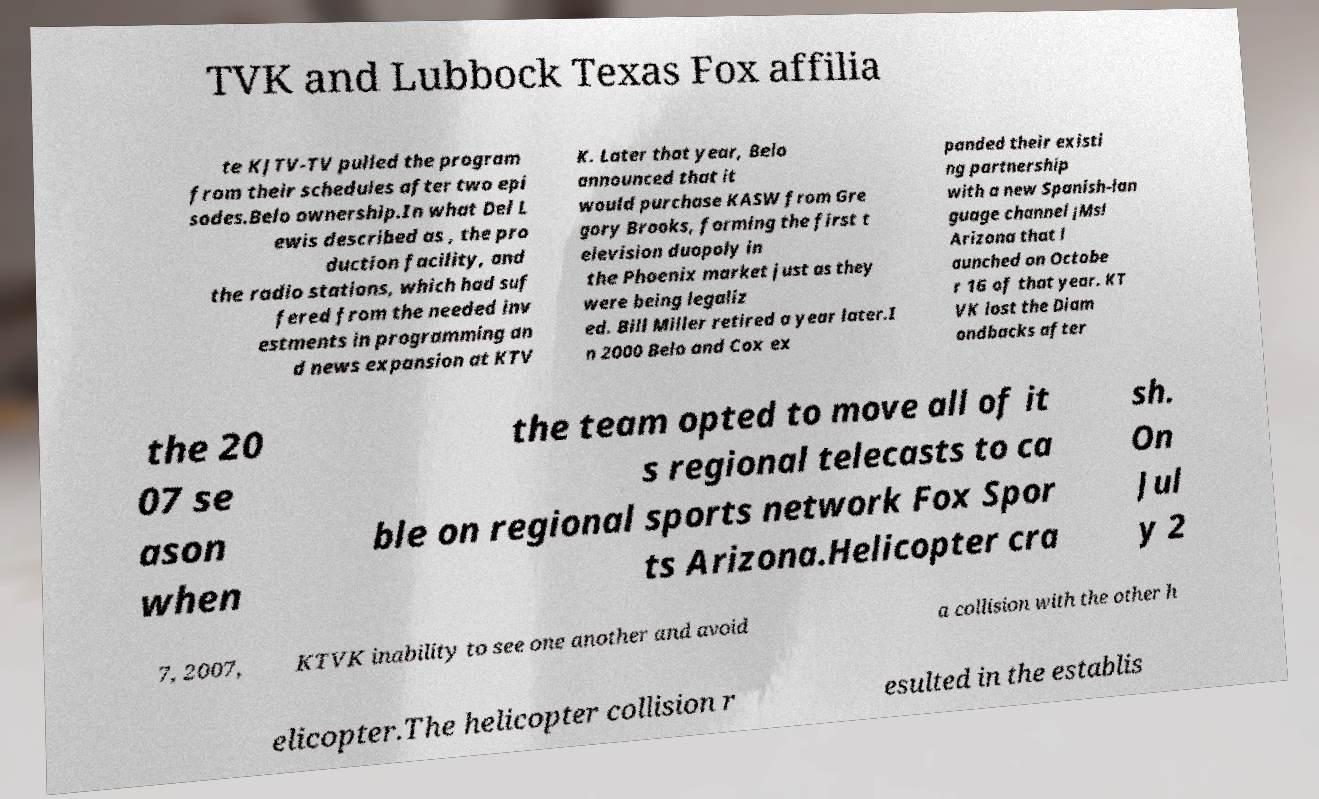Can you accurately transcribe the text from the provided image for me? TVK and Lubbock Texas Fox affilia te KJTV-TV pulled the program from their schedules after two epi sodes.Belo ownership.In what Del L ewis described as , the pro duction facility, and the radio stations, which had suf fered from the needed inv estments in programming an d news expansion at KTV K. Later that year, Belo announced that it would purchase KASW from Gre gory Brooks, forming the first t elevision duopoly in the Phoenix market just as they were being legaliz ed. Bill Miller retired a year later.I n 2000 Belo and Cox ex panded their existi ng partnership with a new Spanish-lan guage channel ¡Ms! Arizona that l aunched on Octobe r 16 of that year. KT VK lost the Diam ondbacks after the 20 07 se ason when the team opted to move all of it s regional telecasts to ca ble on regional sports network Fox Spor ts Arizona.Helicopter cra sh. On Jul y 2 7, 2007, KTVK inability to see one another and avoid a collision with the other h elicopter.The helicopter collision r esulted in the establis 